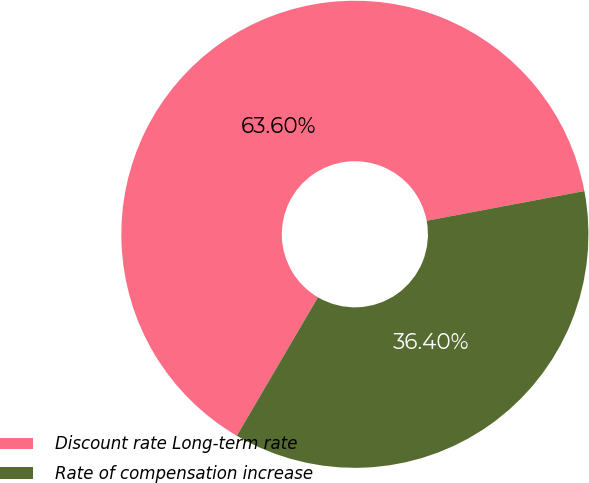Convert chart to OTSL. <chart><loc_0><loc_0><loc_500><loc_500><pie_chart><fcel>Discount rate Long-term rate<fcel>Rate of compensation increase<nl><fcel>63.6%<fcel>36.4%<nl></chart> 